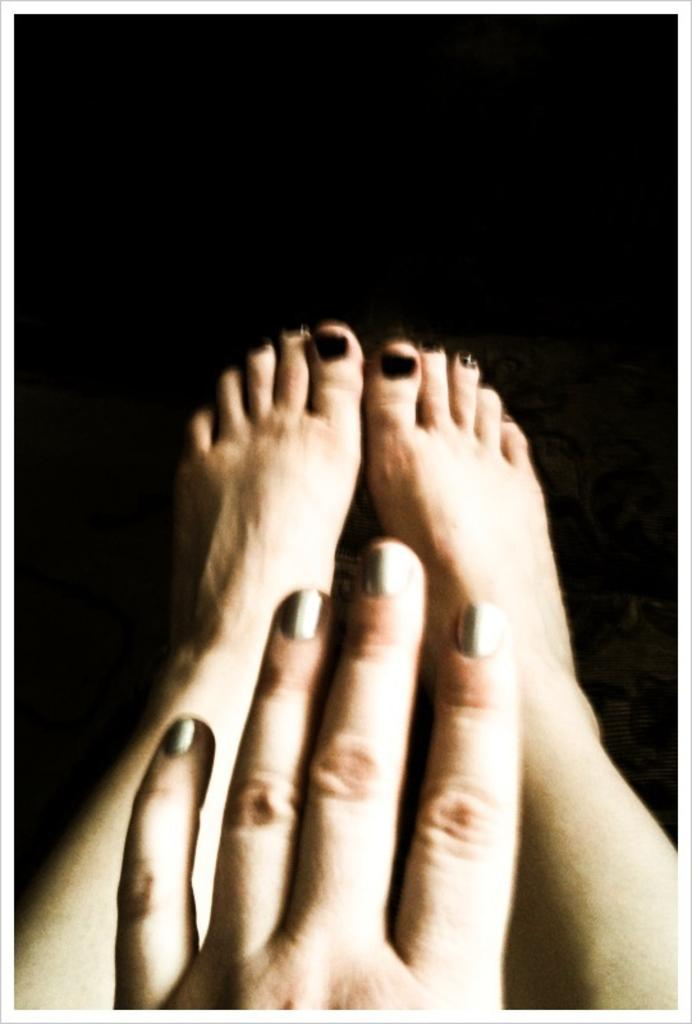What type of vegetable is shown ticking like a clock in the image? There is no vegetable or clock present in the image. 